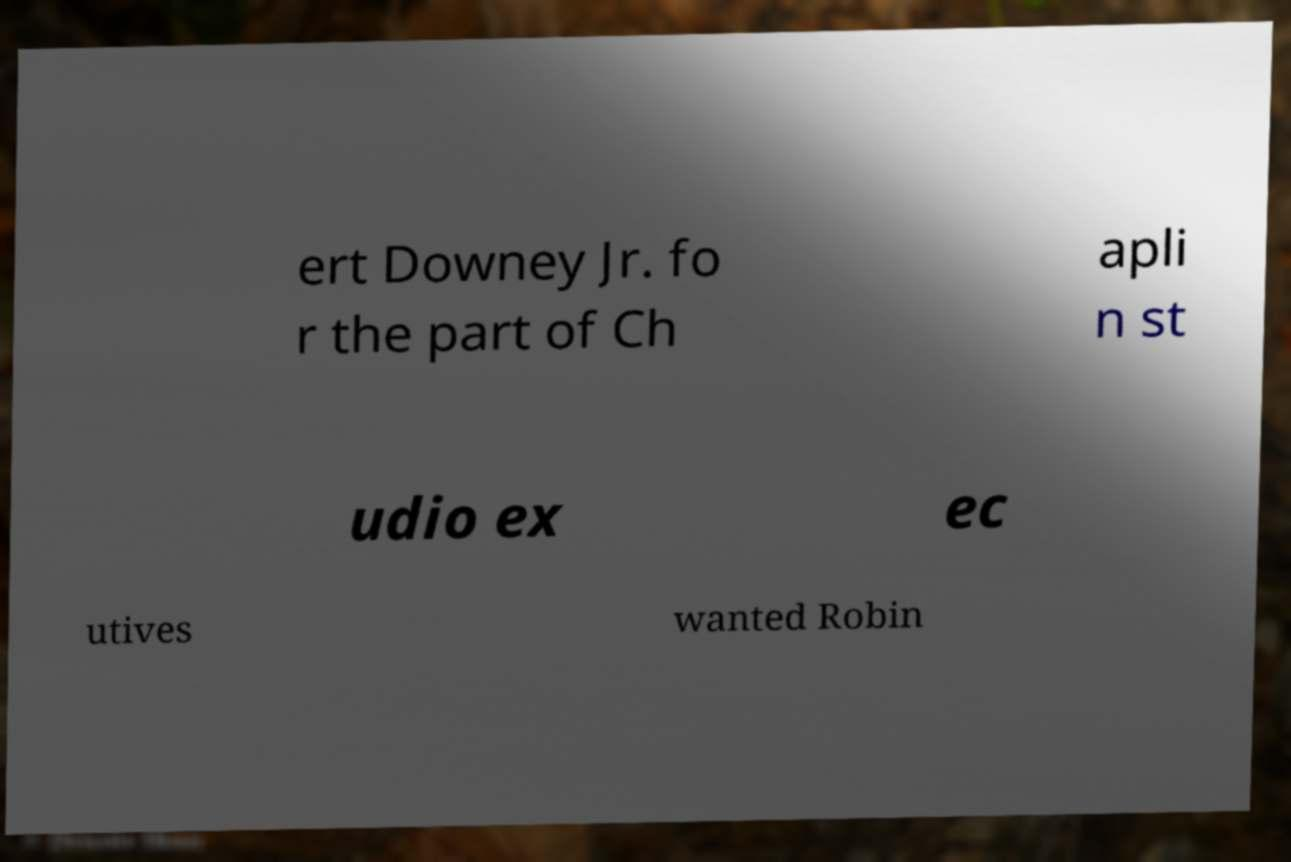Can you accurately transcribe the text from the provided image for me? ert Downey Jr. fo r the part of Ch apli n st udio ex ec utives wanted Robin 